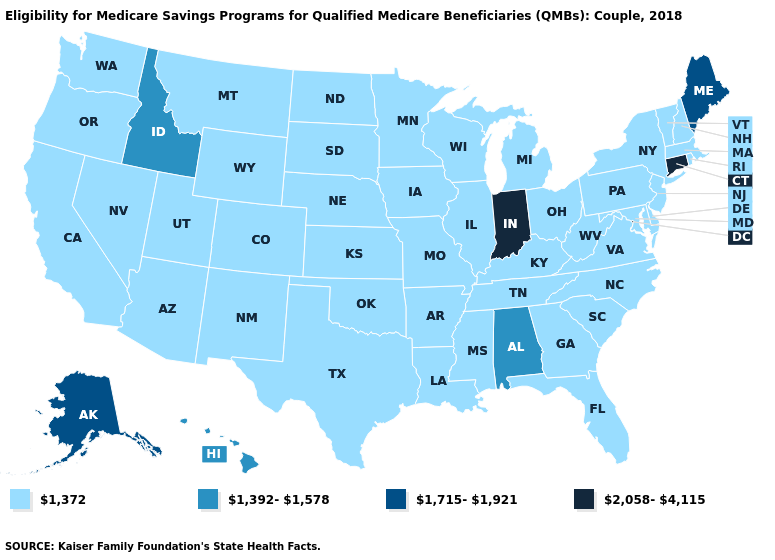Does the map have missing data?
Short answer required. No. Does Louisiana have the highest value in the South?
Keep it brief. No. What is the value of Indiana?
Concise answer only. 2,058-4,115. Which states hav the highest value in the Northeast?
Answer briefly. Connecticut. What is the highest value in the MidWest ?
Write a very short answer. 2,058-4,115. Name the states that have a value in the range 1,372?
Keep it brief. Arizona, Arkansas, California, Colorado, Delaware, Florida, Georgia, Illinois, Iowa, Kansas, Kentucky, Louisiana, Maryland, Massachusetts, Michigan, Minnesota, Mississippi, Missouri, Montana, Nebraska, Nevada, New Hampshire, New Jersey, New Mexico, New York, North Carolina, North Dakota, Ohio, Oklahoma, Oregon, Pennsylvania, Rhode Island, South Carolina, South Dakota, Tennessee, Texas, Utah, Vermont, Virginia, Washington, West Virginia, Wisconsin, Wyoming. Does the map have missing data?
Give a very brief answer. No. Is the legend a continuous bar?
Quick response, please. No. What is the value of Utah?
Be succinct. 1,372. Name the states that have a value in the range 1,392-1,578?
Concise answer only. Alabama, Hawaii, Idaho. Among the states that border Utah , which have the lowest value?
Quick response, please. Arizona, Colorado, Nevada, New Mexico, Wyoming. Among the states that border Wyoming , which have the lowest value?
Write a very short answer. Colorado, Montana, Nebraska, South Dakota, Utah. Which states have the lowest value in the South?
Quick response, please. Arkansas, Delaware, Florida, Georgia, Kentucky, Louisiana, Maryland, Mississippi, North Carolina, Oklahoma, South Carolina, Tennessee, Texas, Virginia, West Virginia. What is the value of Virginia?
Concise answer only. 1,372. 